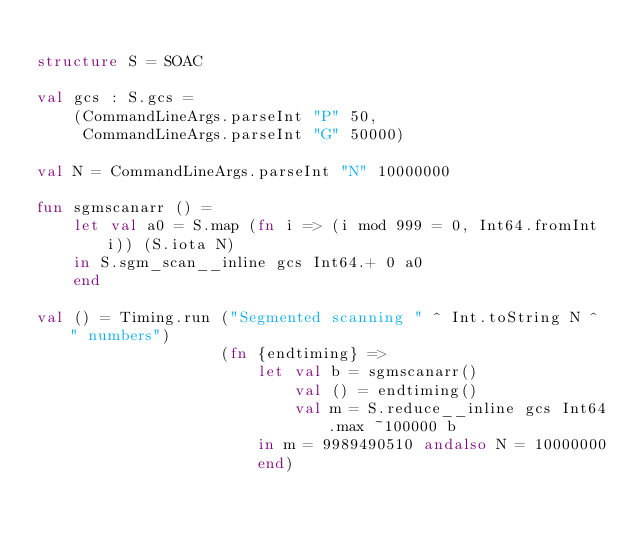<code> <loc_0><loc_0><loc_500><loc_500><_SML_>
structure S = SOAC

val gcs : S.gcs =
    (CommandLineArgs.parseInt "P" 50,
     CommandLineArgs.parseInt "G" 50000)

val N = CommandLineArgs.parseInt "N" 10000000

fun sgmscanarr () =
    let val a0 = S.map (fn i => (i mod 999 = 0, Int64.fromInt i)) (S.iota N)
    in S.sgm_scan__inline gcs Int64.+ 0 a0
    end

val () = Timing.run ("Segmented scanning " ^ Int.toString N ^ " numbers")
                    (fn {endtiming} =>
                        let val b = sgmscanarr()
                            val () = endtiming()
                            val m = S.reduce__inline gcs Int64.max ~100000 b
                        in m = 9989490510 andalso N = 10000000
                        end)
</code> 